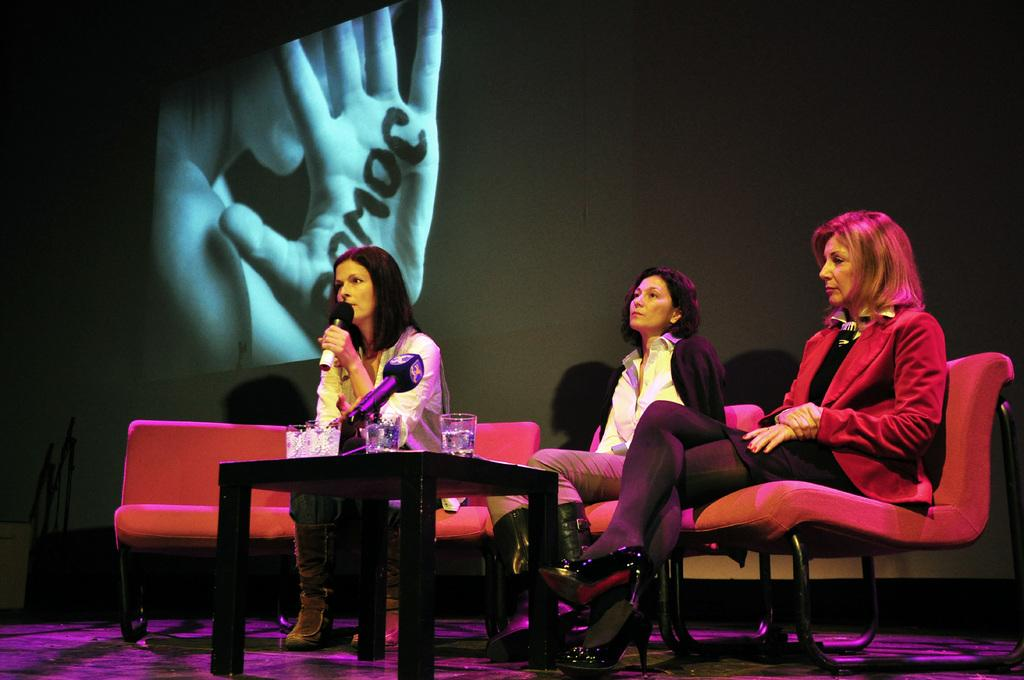How many people are in the image? There are three persons in the image. What is the woman doing in the image? The woman is sitting and holding a microphone. What is the woman wearing in the image? The woman is wearing a white shirt. What objects can be seen on the table in the image? There are glasses and a microphone on the table. What is located at the back of the scene in the image? There is a screen at the back of the scene. Is there any quicksand visible in the image? No, there is no quicksand present in the image. What type of vegetable is being served on the table in the image? There are no vegetables visible on the table in the image. 